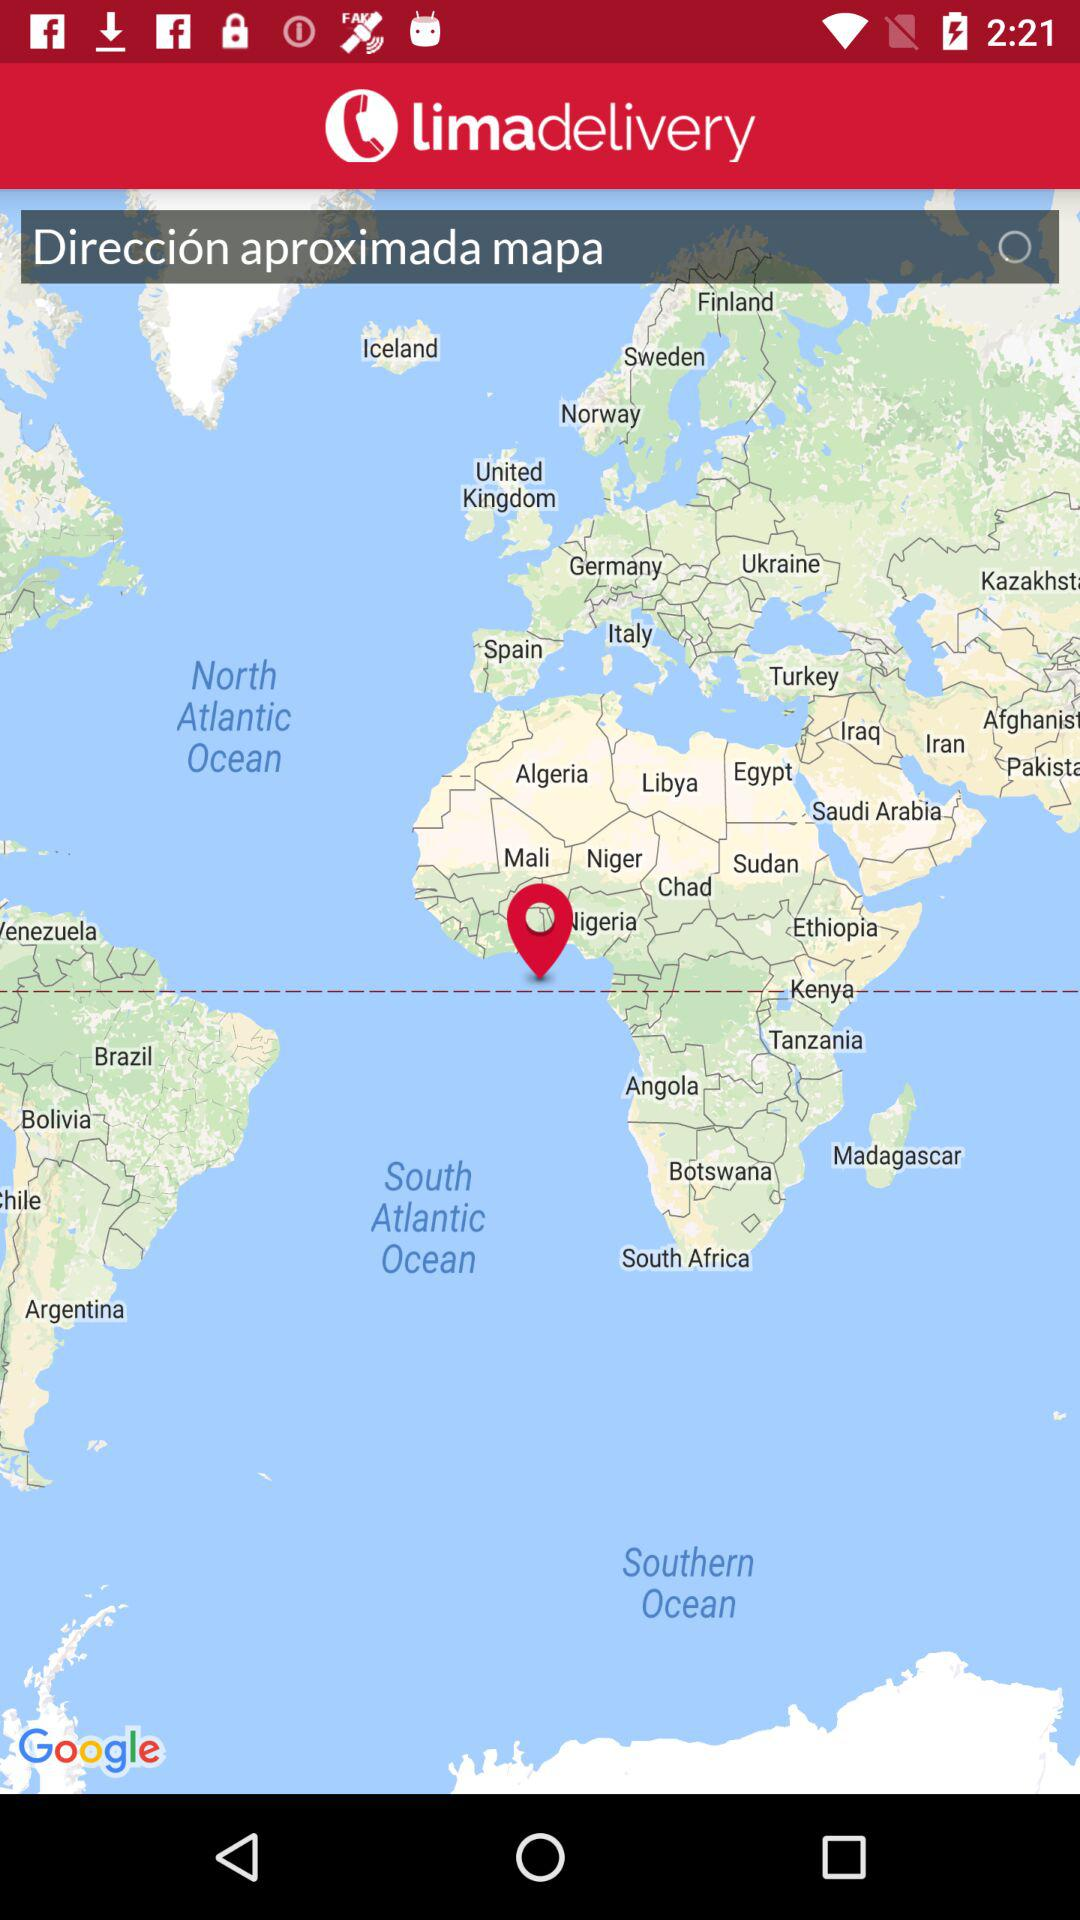What is the name of the application? The name of the application is "Limadelivery". 